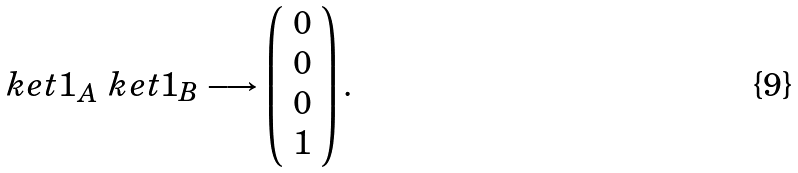<formula> <loc_0><loc_0><loc_500><loc_500>\ k e t { 1 } _ { A } \ k e t { 1 } _ { B } \longrightarrow \left ( \begin{array} { c } 0 \\ 0 \\ 0 \\ 1 \end{array} \right ) .</formula> 